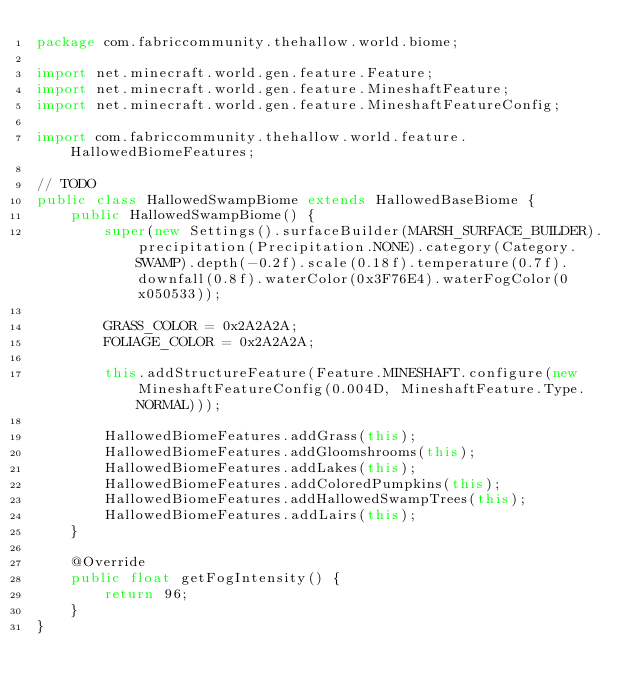Convert code to text. <code><loc_0><loc_0><loc_500><loc_500><_Java_>package com.fabriccommunity.thehallow.world.biome;

import net.minecraft.world.gen.feature.Feature;
import net.minecraft.world.gen.feature.MineshaftFeature;
import net.minecraft.world.gen.feature.MineshaftFeatureConfig;

import com.fabriccommunity.thehallow.world.feature.HallowedBiomeFeatures;

// TODO
public class HallowedSwampBiome extends HallowedBaseBiome {
	public HallowedSwampBiome() {
		super(new Settings().surfaceBuilder(MARSH_SURFACE_BUILDER).precipitation(Precipitation.NONE).category(Category.SWAMP).depth(-0.2f).scale(0.18f).temperature(0.7f).downfall(0.8f).waterColor(0x3F76E4).waterFogColor(0x050533));
		
		GRASS_COLOR = 0x2A2A2A;
		FOLIAGE_COLOR = 0x2A2A2A;
		
		this.addStructureFeature(Feature.MINESHAFT.configure(new MineshaftFeatureConfig(0.004D, MineshaftFeature.Type.NORMAL)));
		
		HallowedBiomeFeatures.addGrass(this);
		HallowedBiomeFeatures.addGloomshrooms(this);
		HallowedBiomeFeatures.addLakes(this);
		HallowedBiomeFeatures.addColoredPumpkins(this);
		HallowedBiomeFeatures.addHallowedSwampTrees(this);
		HallowedBiomeFeatures.addLairs(this);
	}
	
	@Override
	public float getFogIntensity() {
		return 96;
	}
}
</code> 